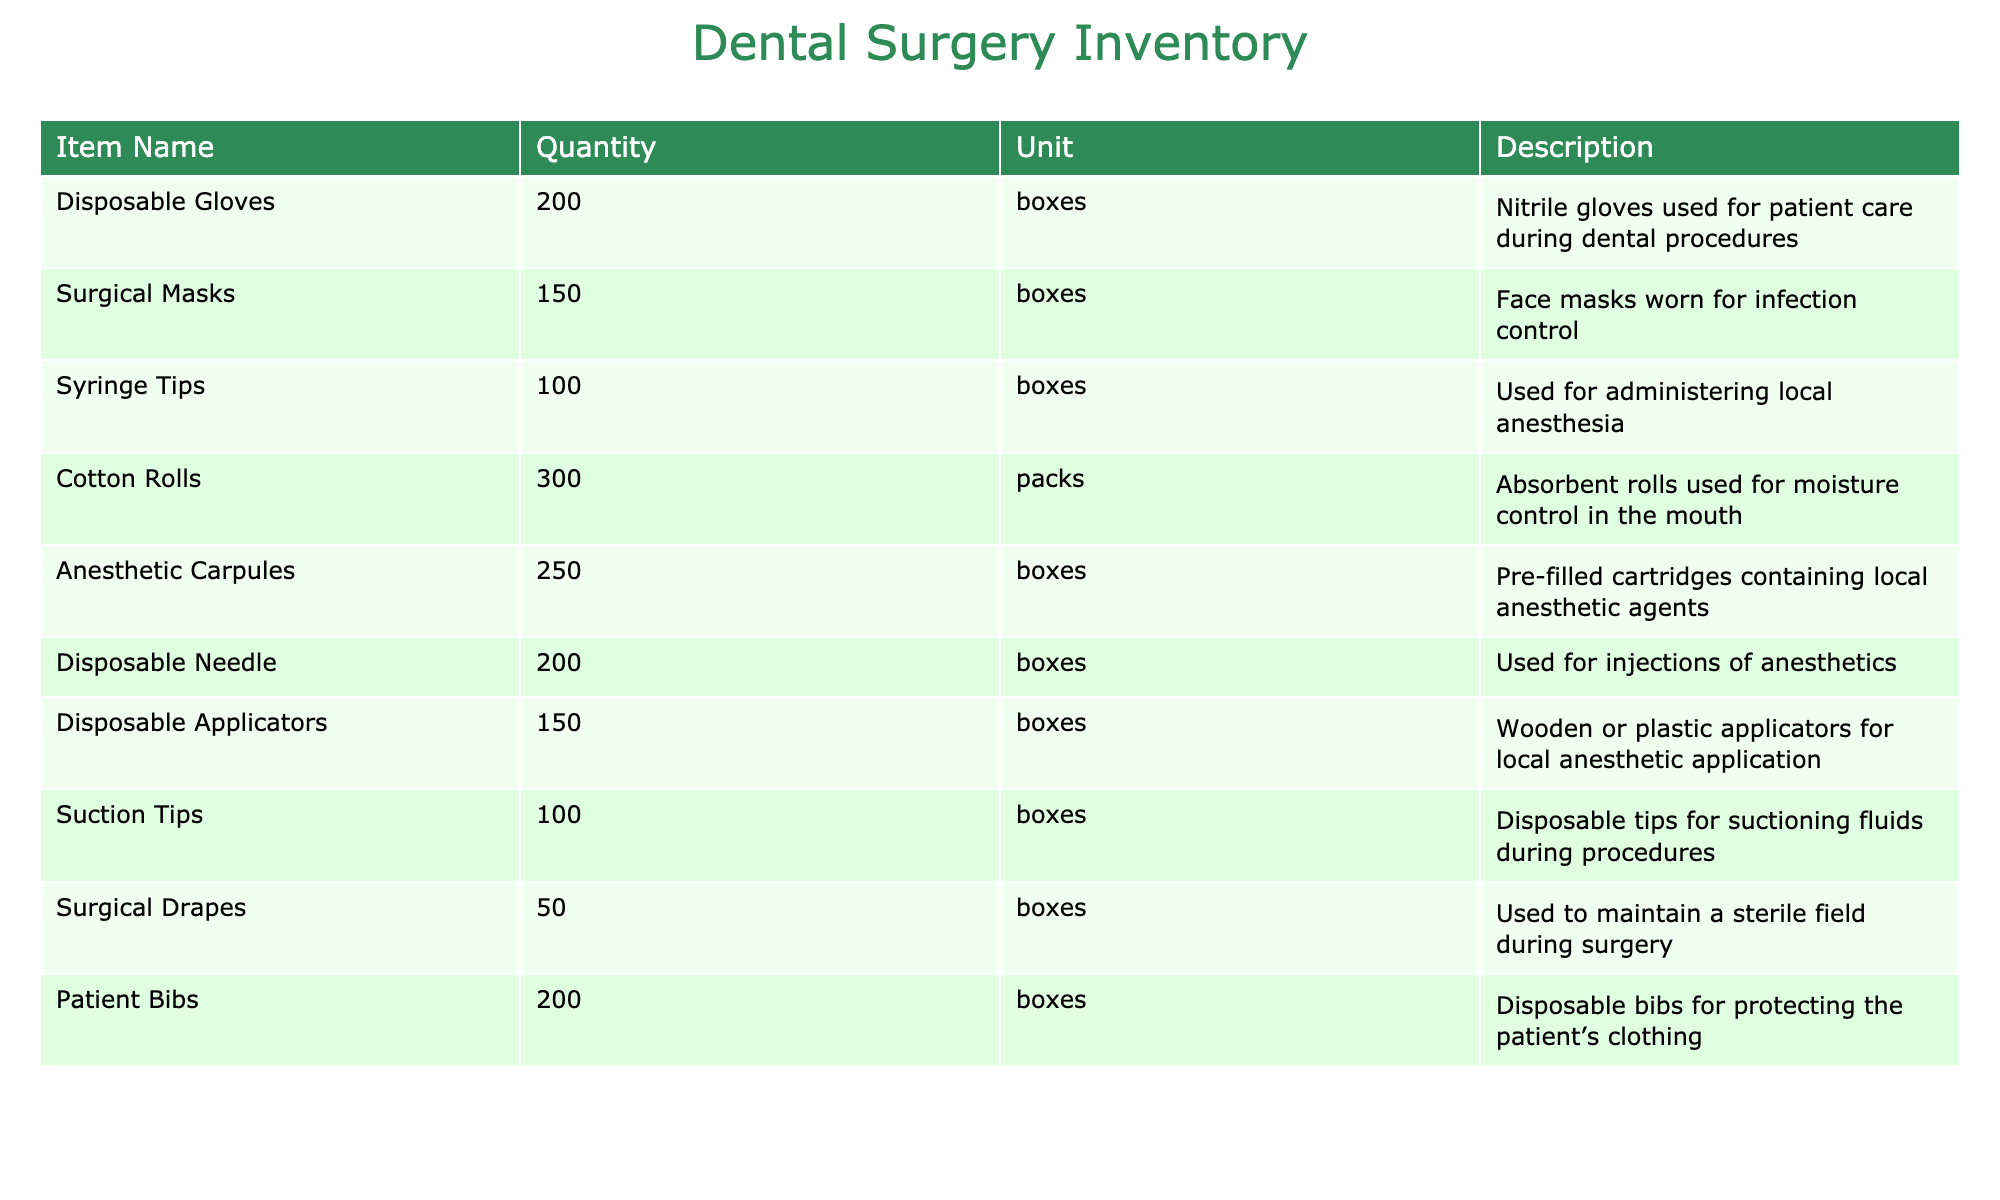What item has the highest quantity in the inventory? Looking at the Quantity column, I see that Cotton Rolls have a quantity of 300, which is higher than any other item listed.
Answer: Cotton Rolls How many boxes of Disposable Gloves are available? The table states that there are 200 boxes of Disposable Gloves listed in the Quantity column.
Answer: 200 boxes Are there more Surgical Masks or Suction Tips available? The Quantity for Surgical Masks is 150 boxes, and for Suction Tips, it is 100 boxes. Therefore, there are more Surgical Masks available than Suction Tips.
Answer: Yes What is the total number of anesthetic supplies (Anesthetic Carpules and Disposable Needle)? The quantity of Anesthetic Carpules is 250 boxes and the quantity of Disposable Needles is 200 boxes. Their sum is 250 + 200 = 450 boxes.
Answer: 450 boxes Is the quantity of Surgical Drapes greater than the combined total of Disposable Applicators and Syringe Tips? The quantity of Surgical Drapes is 50 boxes. The combined total of Disposable Applicators (150 boxes) and Syringe Tips (100 boxes) is 150 + 100 = 250 boxes. Since 50 is less than 250, the quantity of Surgical Drapes is not greater.
Answer: No What percentage of the total inventory does the quantity of Anesthetic Carpules represent? To get the total inventory, I add all the quantities: 200 (Gloves) + 150 (Masks) + 100 (Syringe Tips) + 300 (Cotton Rolls) + 250 (Carpules) + 200 (Needles) + 150 (Applicators) + 100 (Suction Tips) + 50 (Drapes) + 200 (Bibs) = 1600 boxes. The Anesthetic Carpules quantity is 250, so (250/1600) * 100 = 15.625%.
Answer: 15.625% Which item has the least quantity and what is it? By examining the Quantity column, Surgical Drapes has the least quantity at 50 boxes compared to the others listed.
Answer: Surgical Drapes, 50 boxes What is the difference in quantity between the most and least available items? The most available item is Cotton Rolls with 300 boxes and the least available is Surgical Drapes with 50 boxes. The difference is 300 - 50 = 250 boxes.
Answer: 250 boxes How many items listed have a quantity of more than 100 boxes? Analyzing the table, I see that Disposable Gloves (200), Surgical Masks (150), Cotton Rolls (300), Anesthetic Carpules (250), and Disposable Needle (200) are greater than 100 boxes, totaling 5 items.
Answer: 5 items What is the overall total quantity of all items, and how does that compare to the total quantity of Patient Bibs? The overall total quantity is calculated as 1600 boxes. The quantity of Patient Bibs is 200 boxes. Comparing, 1600 is significantly higher than 200.
Answer: Overall total: 1600 boxes; Comparison: Higher 